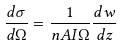Convert formula to latex. <formula><loc_0><loc_0><loc_500><loc_500>\frac { d \sigma } { d \Omega } = \frac { 1 } { n A I \Omega } \frac { d w } { d z }</formula> 